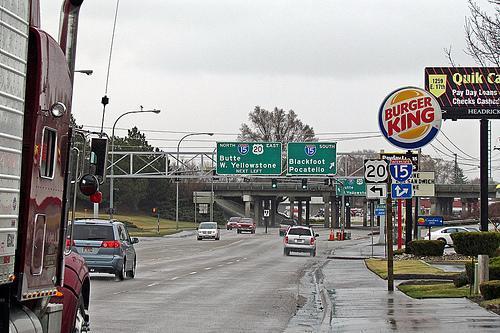How many restaurant signs are visible?
Give a very brief answer. 1. 